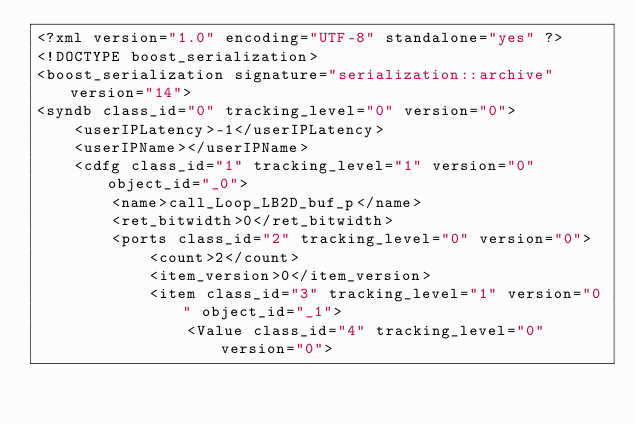<code> <loc_0><loc_0><loc_500><loc_500><_Ada_><?xml version="1.0" encoding="UTF-8" standalone="yes" ?>
<!DOCTYPE boost_serialization>
<boost_serialization signature="serialization::archive" version="14">
<syndb class_id="0" tracking_level="0" version="0">
	<userIPLatency>-1</userIPLatency>
	<userIPName></userIPName>
	<cdfg class_id="1" tracking_level="1" version="0" object_id="_0">
		<name>call_Loop_LB2D_buf_p</name>
		<ret_bitwidth>0</ret_bitwidth>
		<ports class_id="2" tracking_level="0" version="0">
			<count>2</count>
			<item_version>0</item_version>
			<item class_id="3" tracking_level="1" version="0" object_id="_1">
				<Value class_id="4" tracking_level="0" version="0"></code> 